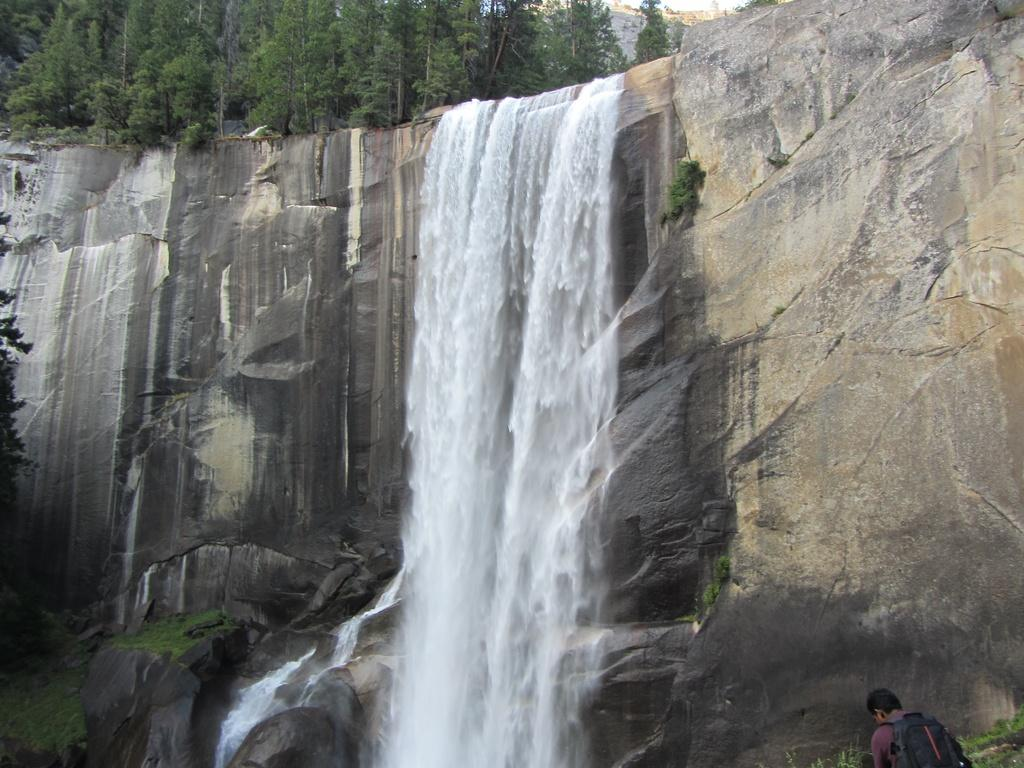What natural feature is the main subject of the image? There is a waterfall in the image. Where is the water coming from in the image? The water is flowing from a hill in the image. What type of vegetation can be seen in the image? There are trees with branches and leaves in the image. Can you describe the person in the image? There is a person with a bag at the bottom right side of the image. What type of dress is the egg wearing in the image? There is no egg or dress present in the image. How much profit can be seen in the image? There is no mention of profit in the image; it features a waterfall, a hill, trees, and a person with a bag. 